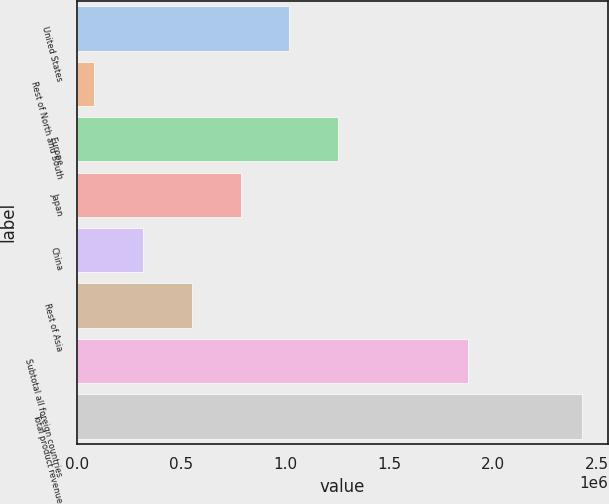Convert chart to OTSL. <chart><loc_0><loc_0><loc_500><loc_500><bar_chart><fcel>United States<fcel>Rest of North and South<fcel>Europe<fcel>Japan<fcel>China<fcel>Rest of Asia<fcel>Subtotal all foreign countries<fcel>Total product revenue<nl><fcel>1.02154e+06<fcel>82761<fcel>1.25624e+06<fcel>786849<fcel>317457<fcel>552153<fcel>1.87854e+06<fcel>2.42972e+06<nl></chart> 